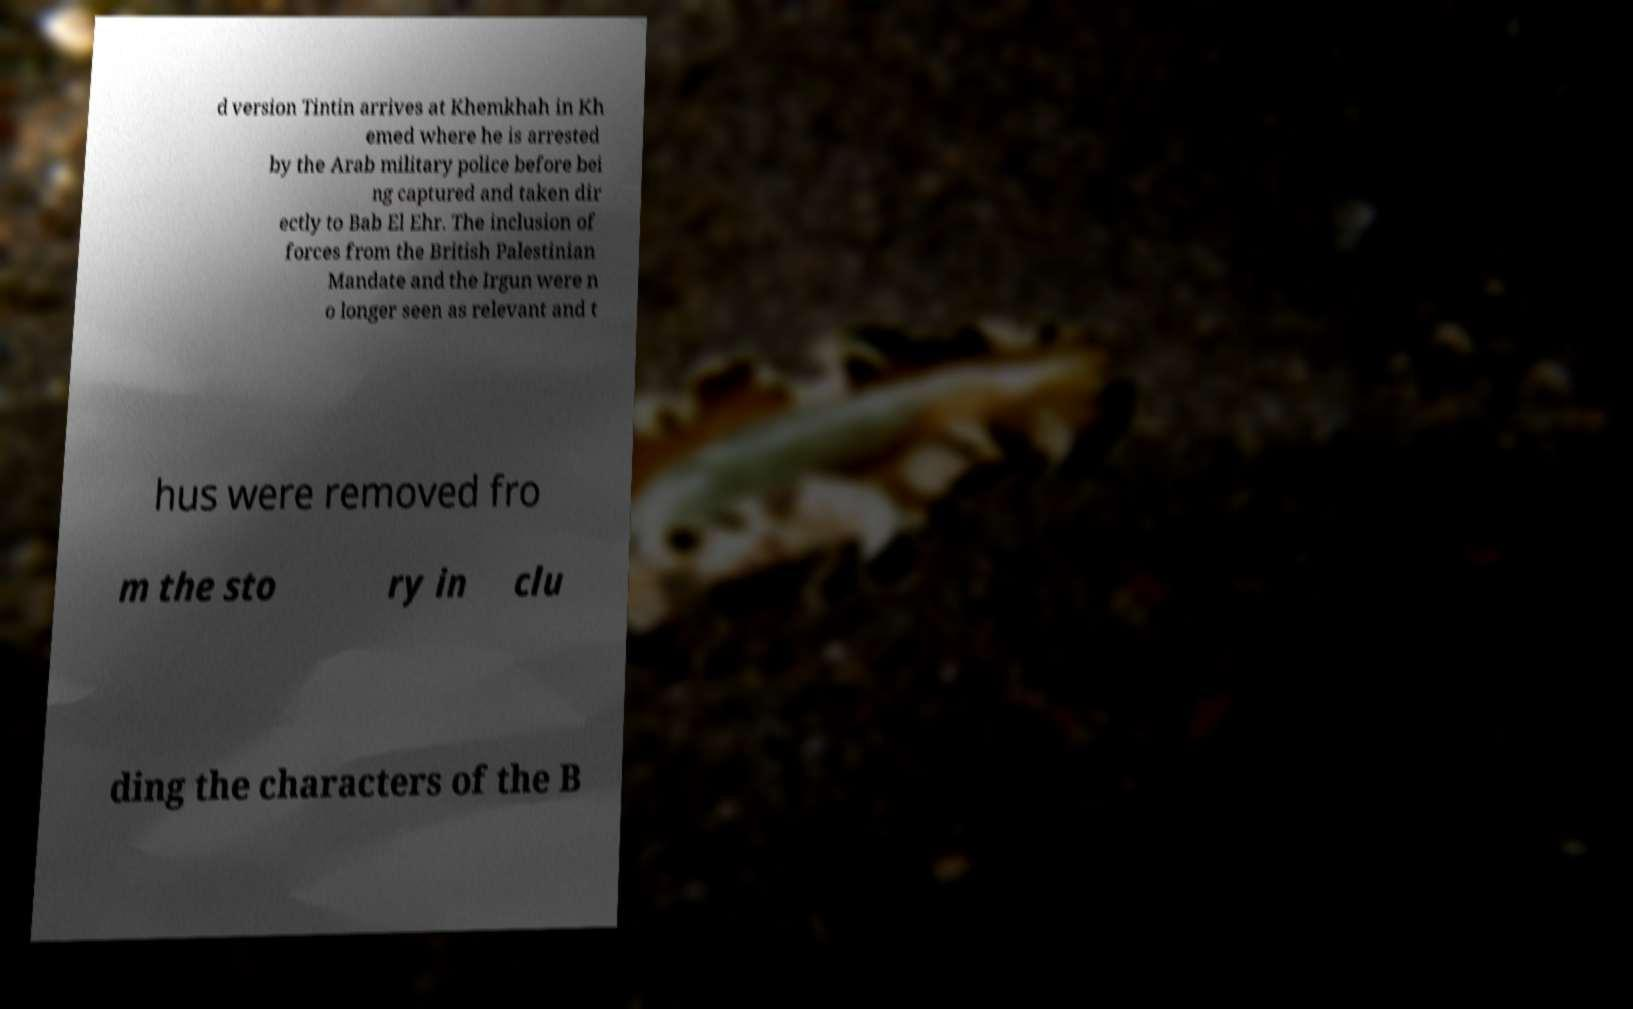Please identify and transcribe the text found in this image. d version Tintin arrives at Khemkhah in Kh emed where he is arrested by the Arab military police before bei ng captured and taken dir ectly to Bab El Ehr. The inclusion of forces from the British Palestinian Mandate and the Irgun were n o longer seen as relevant and t hus were removed fro m the sto ry in clu ding the characters of the B 